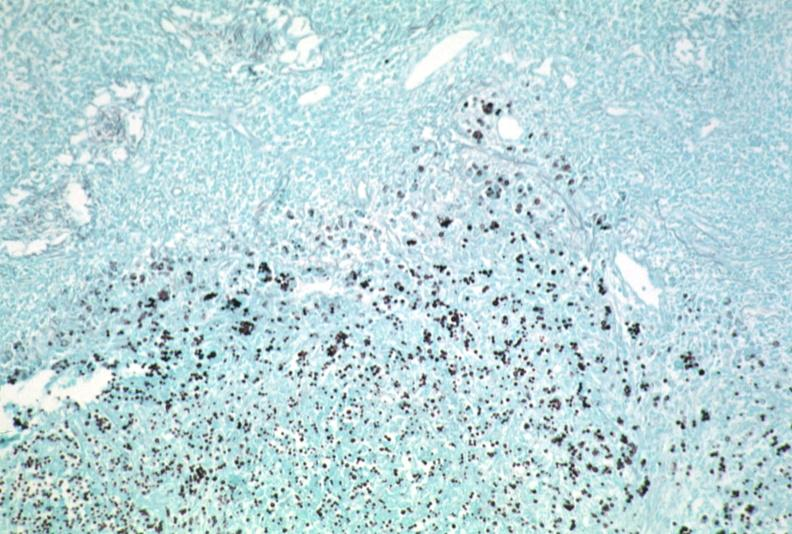what does this image show?
Answer the question using a single word or phrase. Lymph node 